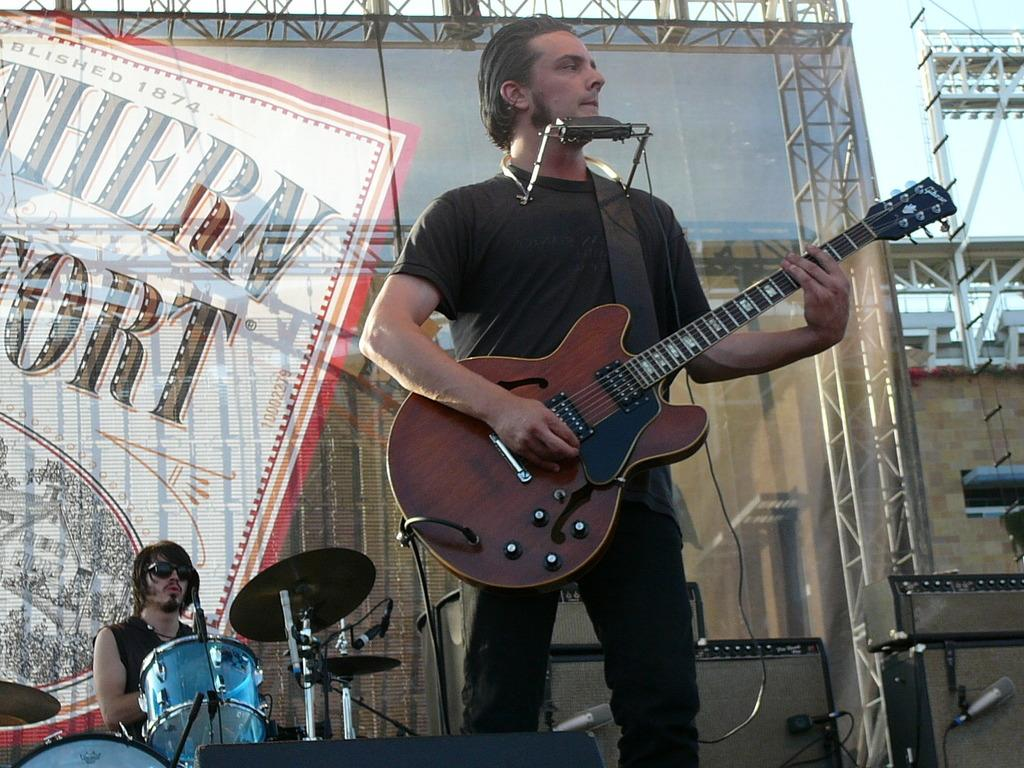What is the man in the image doing? The man is standing and holding a guitar in his hand. Can you describe the other person in the image? The other person is sitting and playing drums. What instrument is the man holding? The man is holding a guitar. What is the sitting person doing with the drums? The sitting person is playing the drums. Are there any cables visible in the image? There is no mention of cables in the provided facts, so we cannot determine if any are visible in the image. 